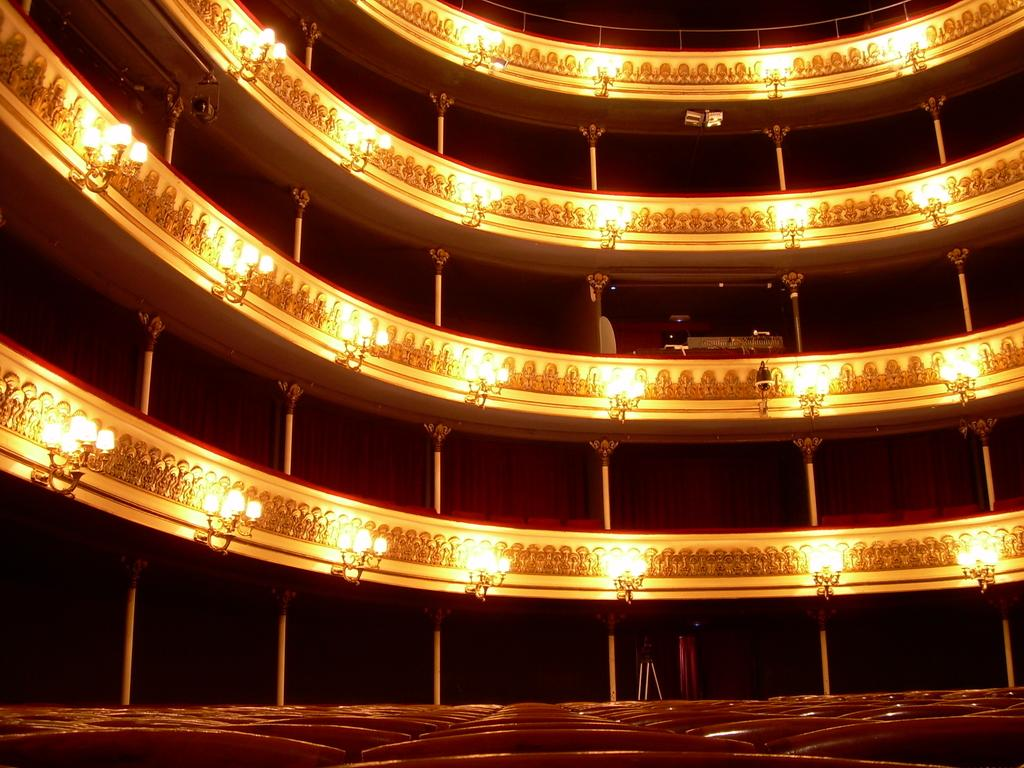What type of location is depicted in the image? The image is an inside view of a building. What architectural features can be seen in the image? There are pillars and railings in the image. What type of window treatment is present in the image? There are curtains in the image. What type of furniture is visible in the image? There are chairs in the image. What type of lighting fixture is present in the image? There is at least one chandelier in the image. What type of stand is present in the image? There is a stand in the image. What other objects can be seen in the image? There are additional objects in the image. Can you see any mice running around in the wilderness in the image? There is no wilderness or mice present in the image; it is an inside view of a building with various architectural and decorative elements. 